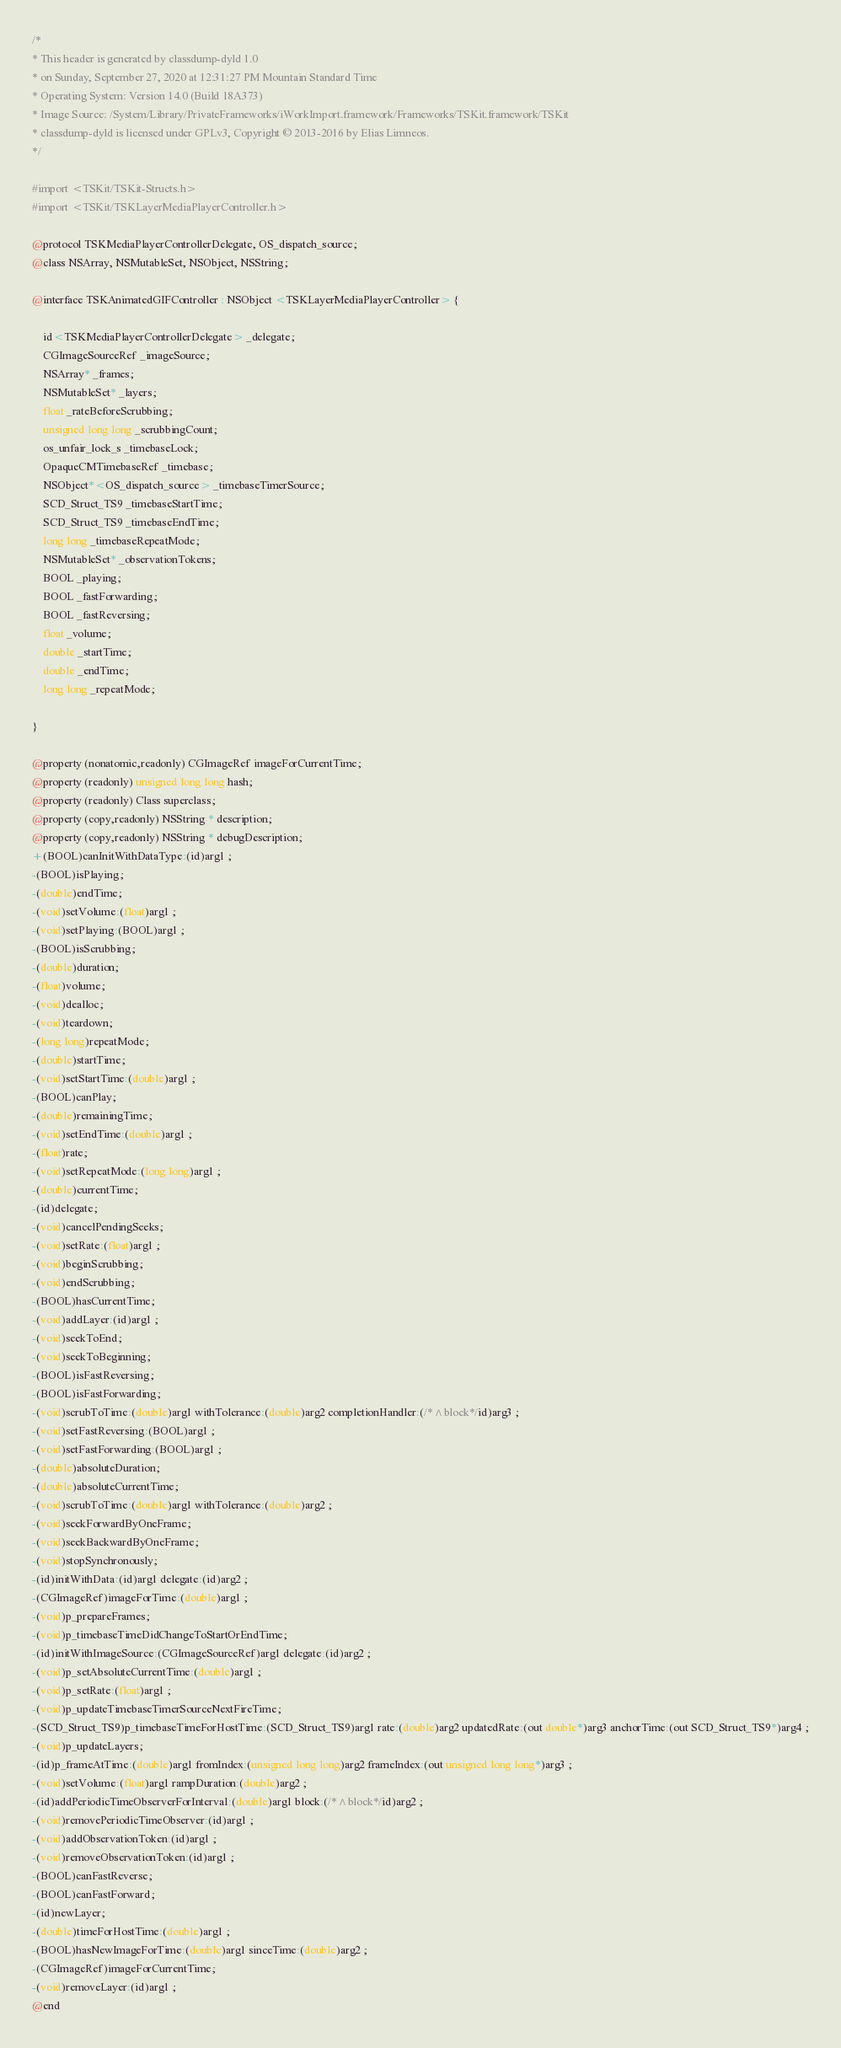<code> <loc_0><loc_0><loc_500><loc_500><_C_>/*
* This header is generated by classdump-dyld 1.0
* on Sunday, September 27, 2020 at 12:31:27 PM Mountain Standard Time
* Operating System: Version 14.0 (Build 18A373)
* Image Source: /System/Library/PrivateFrameworks/iWorkImport.framework/Frameworks/TSKit.framework/TSKit
* classdump-dyld is licensed under GPLv3, Copyright © 2013-2016 by Elias Limneos.
*/

#import <TSKit/TSKit-Structs.h>
#import <TSKit/TSKLayerMediaPlayerController.h>

@protocol TSKMediaPlayerControllerDelegate, OS_dispatch_source;
@class NSArray, NSMutableSet, NSObject, NSString;

@interface TSKAnimatedGIFController : NSObject <TSKLayerMediaPlayerController> {

	id<TSKMediaPlayerControllerDelegate> _delegate;
	CGImageSourceRef _imageSource;
	NSArray* _frames;
	NSMutableSet* _layers;
	float _rateBeforeScrubbing;
	unsigned long long _scrubbingCount;
	os_unfair_lock_s _timebaseLock;
	OpaqueCMTimebaseRef _timebase;
	NSObject*<OS_dispatch_source> _timebaseTimerSource;
	SCD_Struct_TS9 _timebaseStartTime;
	SCD_Struct_TS9 _timebaseEndTime;
	long long _timebaseRepeatMode;
	NSMutableSet* _observationTokens;
	BOOL _playing;
	BOOL _fastForwarding;
	BOOL _fastReversing;
	float _volume;
	double _startTime;
	double _endTime;
	long long _repeatMode;

}

@property (nonatomic,readonly) CGImageRef imageForCurrentTime; 
@property (readonly) unsigned long long hash; 
@property (readonly) Class superclass; 
@property (copy,readonly) NSString * description; 
@property (copy,readonly) NSString * debugDescription; 
+(BOOL)canInitWithDataType:(id)arg1 ;
-(BOOL)isPlaying;
-(double)endTime;
-(void)setVolume:(float)arg1 ;
-(void)setPlaying:(BOOL)arg1 ;
-(BOOL)isScrubbing;
-(double)duration;
-(float)volume;
-(void)dealloc;
-(void)teardown;
-(long long)repeatMode;
-(double)startTime;
-(void)setStartTime:(double)arg1 ;
-(BOOL)canPlay;
-(double)remainingTime;
-(void)setEndTime:(double)arg1 ;
-(float)rate;
-(void)setRepeatMode:(long long)arg1 ;
-(double)currentTime;
-(id)delegate;
-(void)cancelPendingSeeks;
-(void)setRate:(float)arg1 ;
-(void)beginScrubbing;
-(void)endScrubbing;
-(BOOL)hasCurrentTime;
-(void)addLayer:(id)arg1 ;
-(void)seekToEnd;
-(void)seekToBeginning;
-(BOOL)isFastReversing;
-(BOOL)isFastForwarding;
-(void)scrubToTime:(double)arg1 withTolerance:(double)arg2 completionHandler:(/*^block*/id)arg3 ;
-(void)setFastReversing:(BOOL)arg1 ;
-(void)setFastForwarding:(BOOL)arg1 ;
-(double)absoluteDuration;
-(double)absoluteCurrentTime;
-(void)scrubToTime:(double)arg1 withTolerance:(double)arg2 ;
-(void)seekForwardByOneFrame;
-(void)seekBackwardByOneFrame;
-(void)stopSynchronously;
-(id)initWithData:(id)arg1 delegate:(id)arg2 ;
-(CGImageRef)imageForTime:(double)arg1 ;
-(void)p_prepareFrames;
-(void)p_timebaseTimeDidChangeToStartOrEndTime;
-(id)initWithImageSource:(CGImageSourceRef)arg1 delegate:(id)arg2 ;
-(void)p_setAbsoluteCurrentTime:(double)arg1 ;
-(void)p_setRate:(float)arg1 ;
-(void)p_updateTimebaseTimerSourceNextFireTime;
-(SCD_Struct_TS9)p_timebaseTimeForHostTime:(SCD_Struct_TS9)arg1 rate:(double)arg2 updatedRate:(out double*)arg3 anchorTime:(out SCD_Struct_TS9*)arg4 ;
-(void)p_updateLayers;
-(id)p_frameAtTime:(double)arg1 fromIndex:(unsigned long long)arg2 frameIndex:(out unsigned long long*)arg3 ;
-(void)setVolume:(float)arg1 rampDuration:(double)arg2 ;
-(id)addPeriodicTimeObserverForInterval:(double)arg1 block:(/*^block*/id)arg2 ;
-(void)removePeriodicTimeObserver:(id)arg1 ;
-(void)addObservationToken:(id)arg1 ;
-(void)removeObservationToken:(id)arg1 ;
-(BOOL)canFastReverse;
-(BOOL)canFastForward;
-(id)newLayer;
-(double)timeForHostTime:(double)arg1 ;
-(BOOL)hasNewImageForTime:(double)arg1 sinceTime:(double)arg2 ;
-(CGImageRef)imageForCurrentTime;
-(void)removeLayer:(id)arg1 ;
@end

</code> 